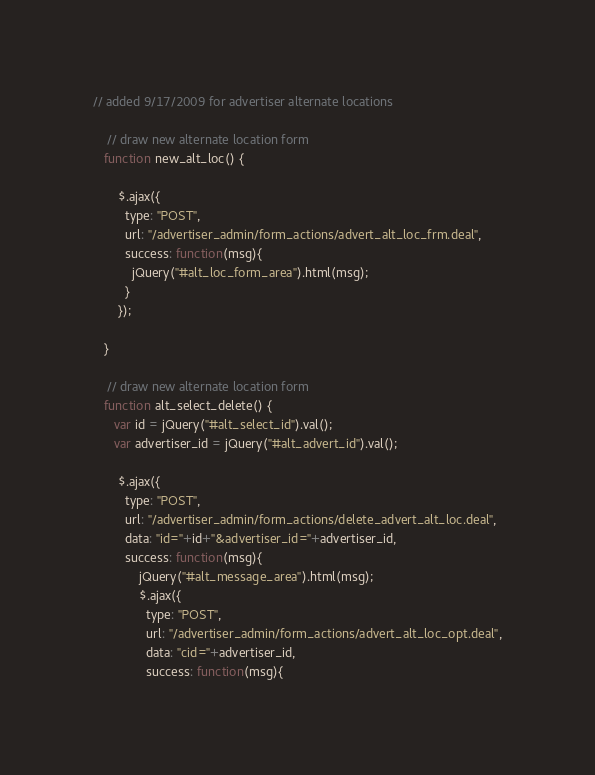<code> <loc_0><loc_0><loc_500><loc_500><_JavaScript_>// added 9/17/2009 for advertiser alternate locations
		
	// draw new alternate location form
   function new_alt_loc() {
	  
	   $.ajax({
		 type: "POST",
		 url: "/advertiser_admin/form_actions/advert_alt_loc_frm.deal",
		 success: function(msg){
		   jQuery("#alt_loc_form_area").html(msg);
		 }
	   });
	   
   }
		
	// draw new alternate location form
   function alt_select_delete() {
	  var id = jQuery("#alt_select_id").val();
	  var advertiser_id = jQuery("#alt_advert_id").val();
	  
	   $.ajax({
		 type: "POST",
		 url: "/advertiser_admin/form_actions/delete_advert_alt_loc.deal",
		 data: "id="+id+"&advertiser_id="+advertiser_id,
		 success: function(msg){
			 jQuery("#alt_message_area").html(msg);
			 $.ajax({
			   type: "POST",
			   url: "/advertiser_admin/form_actions/advert_alt_loc_opt.deal",
			   data: "cid="+advertiser_id,
			   success: function(msg){</code> 